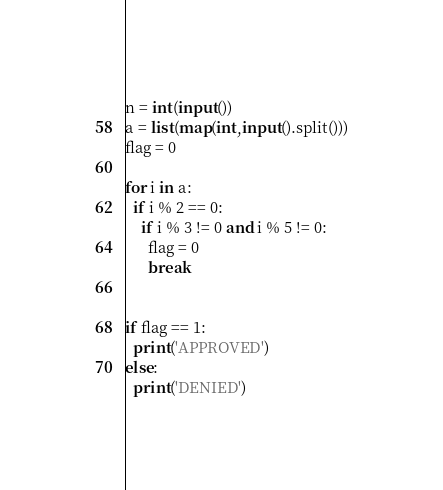Convert code to text. <code><loc_0><loc_0><loc_500><loc_500><_Python_>n = int(input())
a = list(map(int,input().split()))
flag = 0
 
for i in a:
  if i % 2 == 0:
    if i % 3 != 0 and i % 5 != 0:
      flag = 0
      break
      
  
if flag == 1:
  print('APPROVED')
else:
  print('DENIED')</code> 